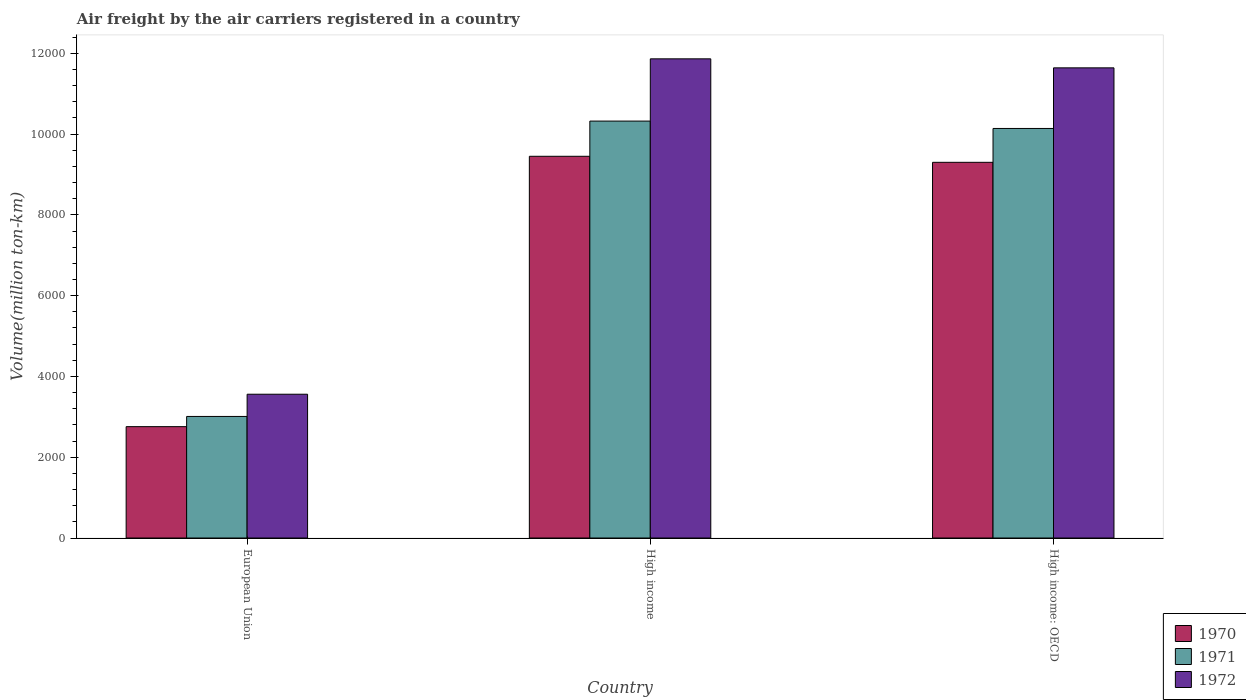How many different coloured bars are there?
Ensure brevity in your answer.  3. Are the number of bars per tick equal to the number of legend labels?
Offer a very short reply. Yes. Are the number of bars on each tick of the X-axis equal?
Offer a very short reply. Yes. What is the label of the 2nd group of bars from the left?
Offer a very short reply. High income. What is the volume of the air carriers in 1972 in High income: OECD?
Your response must be concise. 1.16e+04. Across all countries, what is the maximum volume of the air carriers in 1970?
Offer a terse response. 9450. Across all countries, what is the minimum volume of the air carriers in 1970?
Your answer should be very brief. 2756.8. In which country was the volume of the air carriers in 1970 minimum?
Provide a short and direct response. European Union. What is the total volume of the air carriers in 1971 in the graph?
Provide a short and direct response. 2.35e+04. What is the difference between the volume of the air carriers in 1971 in High income and that in High income: OECD?
Your answer should be compact. 182.7. What is the difference between the volume of the air carriers in 1972 in High income and the volume of the air carriers in 1971 in High income: OECD?
Your response must be concise. 1723.7. What is the average volume of the air carriers in 1971 per country?
Provide a short and direct response. 7823.5. What is the difference between the volume of the air carriers of/in 1971 and volume of the air carriers of/in 1972 in High income?
Ensure brevity in your answer.  -1541. What is the ratio of the volume of the air carriers in 1971 in European Union to that in High income?
Keep it short and to the point. 0.29. Is the volume of the air carriers in 1971 in High income less than that in High income: OECD?
Your response must be concise. No. Is the difference between the volume of the air carriers in 1971 in European Union and High income greater than the difference between the volume of the air carriers in 1972 in European Union and High income?
Ensure brevity in your answer.  Yes. What is the difference between the highest and the second highest volume of the air carriers in 1972?
Offer a very short reply. -8303.3. What is the difference between the highest and the lowest volume of the air carriers in 1971?
Offer a terse response. 7312.5. What is the difference between two consecutive major ticks on the Y-axis?
Make the answer very short. 2000. Does the graph contain grids?
Make the answer very short. No. Where does the legend appear in the graph?
Make the answer very short. Bottom right. How many legend labels are there?
Offer a very short reply. 3. How are the legend labels stacked?
Provide a succinct answer. Vertical. What is the title of the graph?
Your answer should be compact. Air freight by the air carriers registered in a country. Does "2001" appear as one of the legend labels in the graph?
Keep it short and to the point. No. What is the label or title of the X-axis?
Provide a short and direct response. Country. What is the label or title of the Y-axis?
Keep it short and to the point. Volume(million ton-km). What is the Volume(million ton-km) in 1970 in European Union?
Provide a short and direct response. 2756.8. What is the Volume(million ton-km) in 1971 in European Union?
Make the answer very short. 3009.4. What is the Volume(million ton-km) in 1972 in European Union?
Offer a very short reply. 3559.6. What is the Volume(million ton-km) of 1970 in High income?
Keep it short and to the point. 9450. What is the Volume(million ton-km) in 1971 in High income?
Give a very brief answer. 1.03e+04. What is the Volume(million ton-km) in 1972 in High income?
Offer a very short reply. 1.19e+04. What is the Volume(million ton-km) in 1970 in High income: OECD?
Ensure brevity in your answer.  9300.9. What is the Volume(million ton-km) in 1971 in High income: OECD?
Offer a terse response. 1.01e+04. What is the Volume(million ton-km) of 1972 in High income: OECD?
Ensure brevity in your answer.  1.16e+04. Across all countries, what is the maximum Volume(million ton-km) in 1970?
Provide a short and direct response. 9450. Across all countries, what is the maximum Volume(million ton-km) in 1971?
Ensure brevity in your answer.  1.03e+04. Across all countries, what is the maximum Volume(million ton-km) in 1972?
Your response must be concise. 1.19e+04. Across all countries, what is the minimum Volume(million ton-km) in 1970?
Your answer should be compact. 2756.8. Across all countries, what is the minimum Volume(million ton-km) of 1971?
Keep it short and to the point. 3009.4. Across all countries, what is the minimum Volume(million ton-km) of 1972?
Ensure brevity in your answer.  3559.6. What is the total Volume(million ton-km) in 1970 in the graph?
Ensure brevity in your answer.  2.15e+04. What is the total Volume(million ton-km) in 1971 in the graph?
Offer a terse response. 2.35e+04. What is the total Volume(million ton-km) in 1972 in the graph?
Keep it short and to the point. 2.71e+04. What is the difference between the Volume(million ton-km) of 1970 in European Union and that in High income?
Your response must be concise. -6693.2. What is the difference between the Volume(million ton-km) in 1971 in European Union and that in High income?
Give a very brief answer. -7312.5. What is the difference between the Volume(million ton-km) of 1972 in European Union and that in High income?
Ensure brevity in your answer.  -8303.3. What is the difference between the Volume(million ton-km) in 1970 in European Union and that in High income: OECD?
Offer a very short reply. -6544.1. What is the difference between the Volume(million ton-km) in 1971 in European Union and that in High income: OECD?
Make the answer very short. -7129.8. What is the difference between the Volume(million ton-km) in 1972 in European Union and that in High income: OECD?
Keep it short and to the point. -8080.1. What is the difference between the Volume(million ton-km) of 1970 in High income and that in High income: OECD?
Provide a short and direct response. 149.1. What is the difference between the Volume(million ton-km) of 1971 in High income and that in High income: OECD?
Provide a short and direct response. 182.7. What is the difference between the Volume(million ton-km) of 1972 in High income and that in High income: OECD?
Your answer should be compact. 223.2. What is the difference between the Volume(million ton-km) in 1970 in European Union and the Volume(million ton-km) in 1971 in High income?
Offer a very short reply. -7565.1. What is the difference between the Volume(million ton-km) of 1970 in European Union and the Volume(million ton-km) of 1972 in High income?
Your answer should be very brief. -9106.1. What is the difference between the Volume(million ton-km) in 1971 in European Union and the Volume(million ton-km) in 1972 in High income?
Your answer should be very brief. -8853.5. What is the difference between the Volume(million ton-km) in 1970 in European Union and the Volume(million ton-km) in 1971 in High income: OECD?
Give a very brief answer. -7382.4. What is the difference between the Volume(million ton-km) in 1970 in European Union and the Volume(million ton-km) in 1972 in High income: OECD?
Provide a succinct answer. -8882.9. What is the difference between the Volume(million ton-km) of 1971 in European Union and the Volume(million ton-km) of 1972 in High income: OECD?
Provide a short and direct response. -8630.3. What is the difference between the Volume(million ton-km) of 1970 in High income and the Volume(million ton-km) of 1971 in High income: OECD?
Offer a very short reply. -689.2. What is the difference between the Volume(million ton-km) of 1970 in High income and the Volume(million ton-km) of 1972 in High income: OECD?
Give a very brief answer. -2189.7. What is the difference between the Volume(million ton-km) in 1971 in High income and the Volume(million ton-km) in 1972 in High income: OECD?
Provide a short and direct response. -1317.8. What is the average Volume(million ton-km) in 1970 per country?
Offer a very short reply. 7169.23. What is the average Volume(million ton-km) of 1971 per country?
Keep it short and to the point. 7823.5. What is the average Volume(million ton-km) of 1972 per country?
Provide a short and direct response. 9020.73. What is the difference between the Volume(million ton-km) in 1970 and Volume(million ton-km) in 1971 in European Union?
Keep it short and to the point. -252.6. What is the difference between the Volume(million ton-km) in 1970 and Volume(million ton-km) in 1972 in European Union?
Give a very brief answer. -802.8. What is the difference between the Volume(million ton-km) in 1971 and Volume(million ton-km) in 1972 in European Union?
Offer a terse response. -550.2. What is the difference between the Volume(million ton-km) in 1970 and Volume(million ton-km) in 1971 in High income?
Provide a succinct answer. -871.9. What is the difference between the Volume(million ton-km) of 1970 and Volume(million ton-km) of 1972 in High income?
Keep it short and to the point. -2412.9. What is the difference between the Volume(million ton-km) in 1971 and Volume(million ton-km) in 1972 in High income?
Ensure brevity in your answer.  -1541. What is the difference between the Volume(million ton-km) of 1970 and Volume(million ton-km) of 1971 in High income: OECD?
Make the answer very short. -838.3. What is the difference between the Volume(million ton-km) of 1970 and Volume(million ton-km) of 1972 in High income: OECD?
Your response must be concise. -2338.8. What is the difference between the Volume(million ton-km) in 1971 and Volume(million ton-km) in 1972 in High income: OECD?
Ensure brevity in your answer.  -1500.5. What is the ratio of the Volume(million ton-km) in 1970 in European Union to that in High income?
Your answer should be compact. 0.29. What is the ratio of the Volume(million ton-km) in 1971 in European Union to that in High income?
Provide a succinct answer. 0.29. What is the ratio of the Volume(million ton-km) of 1972 in European Union to that in High income?
Make the answer very short. 0.3. What is the ratio of the Volume(million ton-km) of 1970 in European Union to that in High income: OECD?
Your response must be concise. 0.3. What is the ratio of the Volume(million ton-km) of 1971 in European Union to that in High income: OECD?
Provide a short and direct response. 0.3. What is the ratio of the Volume(million ton-km) of 1972 in European Union to that in High income: OECD?
Offer a terse response. 0.31. What is the ratio of the Volume(million ton-km) in 1972 in High income to that in High income: OECD?
Give a very brief answer. 1.02. What is the difference between the highest and the second highest Volume(million ton-km) in 1970?
Your response must be concise. 149.1. What is the difference between the highest and the second highest Volume(million ton-km) of 1971?
Offer a very short reply. 182.7. What is the difference between the highest and the second highest Volume(million ton-km) of 1972?
Offer a terse response. 223.2. What is the difference between the highest and the lowest Volume(million ton-km) in 1970?
Offer a terse response. 6693.2. What is the difference between the highest and the lowest Volume(million ton-km) of 1971?
Your response must be concise. 7312.5. What is the difference between the highest and the lowest Volume(million ton-km) in 1972?
Ensure brevity in your answer.  8303.3. 